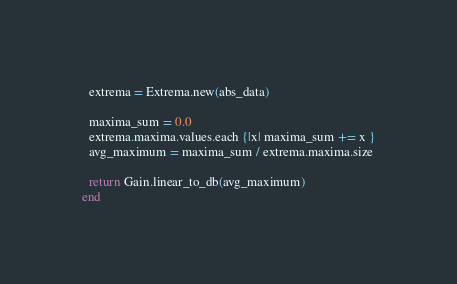<code> <loc_0><loc_0><loc_500><loc_500><_Crystal_>  extrema = Extrema.new(abs_data)

  maxima_sum = 0.0
  extrema.maxima.values.each {|x| maxima_sum += x }
  avg_maximum = maxima_sum / extrema.maxima.size

  return Gain.linear_to_db(avg_maximum)
end
</code> 